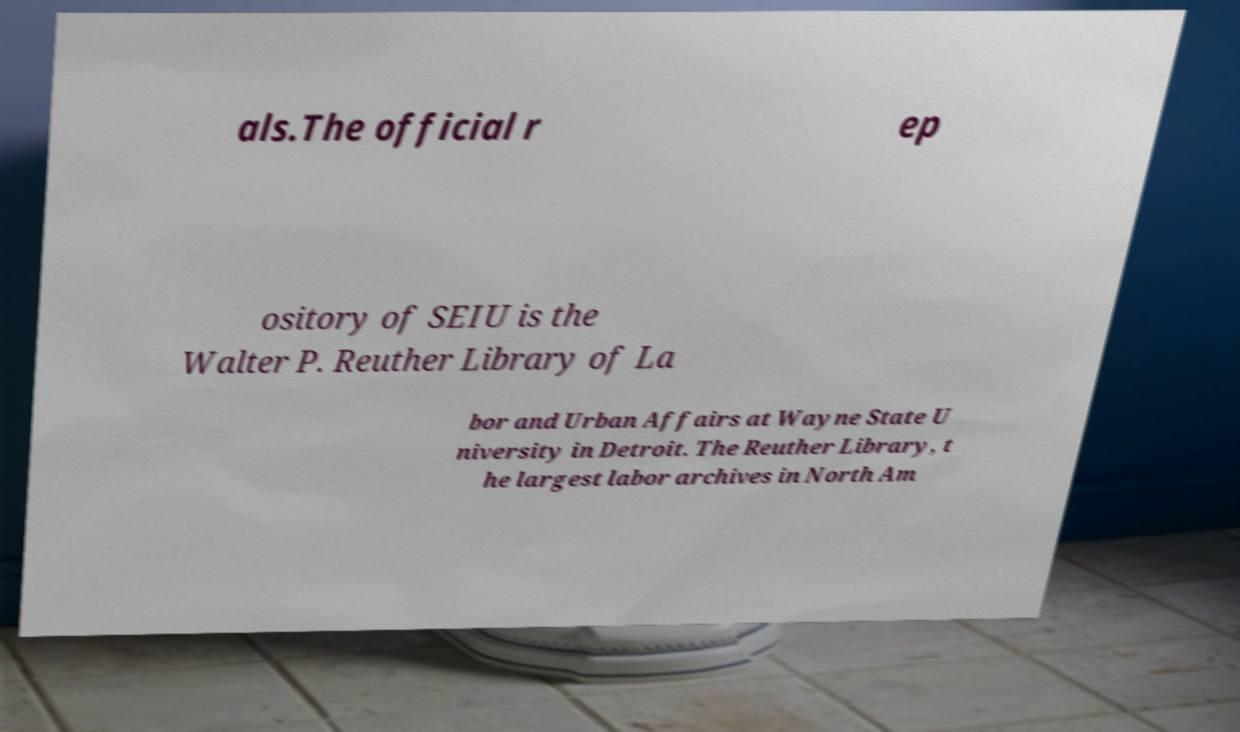Could you extract and type out the text from this image? als.The official r ep ository of SEIU is the Walter P. Reuther Library of La bor and Urban Affairs at Wayne State U niversity in Detroit. The Reuther Library, t he largest labor archives in North Am 